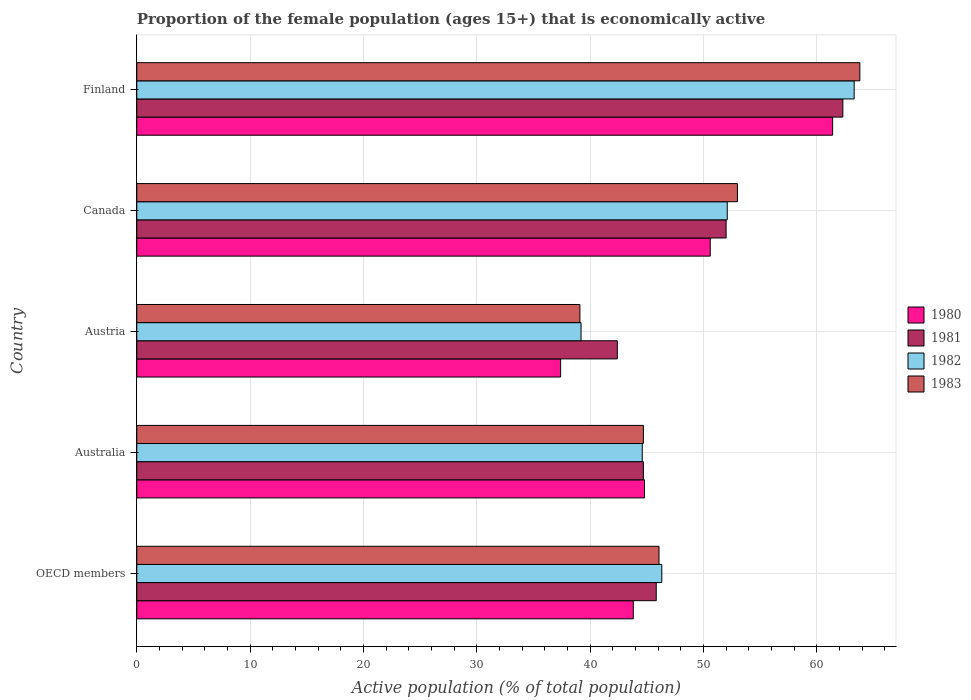Are the number of bars on each tick of the Y-axis equal?
Your response must be concise. Yes. What is the label of the 5th group of bars from the top?
Ensure brevity in your answer.  OECD members. In how many cases, is the number of bars for a given country not equal to the number of legend labels?
Your answer should be compact. 0. What is the proportion of the female population that is economically active in 1980 in Canada?
Your answer should be compact. 50.6. Across all countries, what is the maximum proportion of the female population that is economically active in 1983?
Give a very brief answer. 63.8. Across all countries, what is the minimum proportion of the female population that is economically active in 1981?
Give a very brief answer. 42.4. In which country was the proportion of the female population that is economically active in 1983 maximum?
Provide a short and direct response. Finland. What is the total proportion of the female population that is economically active in 1980 in the graph?
Provide a succinct answer. 238.01. What is the difference between the proportion of the female population that is economically active in 1983 in Austria and that in Canada?
Make the answer very short. -13.9. What is the difference between the proportion of the female population that is economically active in 1982 in OECD members and the proportion of the female population that is economically active in 1981 in Canada?
Make the answer very short. -5.68. What is the average proportion of the female population that is economically active in 1980 per country?
Give a very brief answer. 47.6. What is the difference between the proportion of the female population that is economically active in 1982 and proportion of the female population that is economically active in 1981 in Australia?
Your response must be concise. -0.1. In how many countries, is the proportion of the female population that is economically active in 1983 greater than 52 %?
Your response must be concise. 2. What is the ratio of the proportion of the female population that is economically active in 1983 in Australia to that in Canada?
Provide a succinct answer. 0.84. Is the proportion of the female population that is economically active in 1983 in Austria less than that in Finland?
Ensure brevity in your answer.  Yes. Is the difference between the proportion of the female population that is economically active in 1982 in Australia and Canada greater than the difference between the proportion of the female population that is economically active in 1981 in Australia and Canada?
Offer a terse response. No. What is the difference between the highest and the second highest proportion of the female population that is economically active in 1981?
Give a very brief answer. 10.3. What is the difference between the highest and the lowest proportion of the female population that is economically active in 1982?
Your answer should be very brief. 24.1. In how many countries, is the proportion of the female population that is economically active in 1980 greater than the average proportion of the female population that is economically active in 1980 taken over all countries?
Provide a short and direct response. 2. Is the sum of the proportion of the female population that is economically active in 1981 in Finland and OECD members greater than the maximum proportion of the female population that is economically active in 1980 across all countries?
Ensure brevity in your answer.  Yes. How many bars are there?
Provide a short and direct response. 20. Does the graph contain any zero values?
Keep it short and to the point. No. Where does the legend appear in the graph?
Your response must be concise. Center right. How are the legend labels stacked?
Ensure brevity in your answer.  Vertical. What is the title of the graph?
Offer a very short reply. Proportion of the female population (ages 15+) that is economically active. What is the label or title of the X-axis?
Offer a very short reply. Active population (% of total population). What is the Active population (% of total population) in 1980 in OECD members?
Make the answer very short. 43.81. What is the Active population (% of total population) in 1981 in OECD members?
Offer a terse response. 45.84. What is the Active population (% of total population) of 1982 in OECD members?
Keep it short and to the point. 46.32. What is the Active population (% of total population) of 1983 in OECD members?
Provide a short and direct response. 46.08. What is the Active population (% of total population) in 1980 in Australia?
Your response must be concise. 44.8. What is the Active population (% of total population) of 1981 in Australia?
Give a very brief answer. 44.7. What is the Active population (% of total population) in 1982 in Australia?
Your answer should be very brief. 44.6. What is the Active population (% of total population) of 1983 in Australia?
Your response must be concise. 44.7. What is the Active population (% of total population) in 1980 in Austria?
Offer a very short reply. 37.4. What is the Active population (% of total population) in 1981 in Austria?
Make the answer very short. 42.4. What is the Active population (% of total population) of 1982 in Austria?
Keep it short and to the point. 39.2. What is the Active population (% of total population) in 1983 in Austria?
Keep it short and to the point. 39.1. What is the Active population (% of total population) in 1980 in Canada?
Provide a short and direct response. 50.6. What is the Active population (% of total population) of 1982 in Canada?
Your answer should be compact. 52.1. What is the Active population (% of total population) of 1980 in Finland?
Offer a terse response. 61.4. What is the Active population (% of total population) of 1981 in Finland?
Provide a short and direct response. 62.3. What is the Active population (% of total population) of 1982 in Finland?
Provide a succinct answer. 63.3. What is the Active population (% of total population) of 1983 in Finland?
Your answer should be very brief. 63.8. Across all countries, what is the maximum Active population (% of total population) in 1980?
Your response must be concise. 61.4. Across all countries, what is the maximum Active population (% of total population) of 1981?
Provide a succinct answer. 62.3. Across all countries, what is the maximum Active population (% of total population) in 1982?
Offer a very short reply. 63.3. Across all countries, what is the maximum Active population (% of total population) of 1983?
Ensure brevity in your answer.  63.8. Across all countries, what is the minimum Active population (% of total population) of 1980?
Make the answer very short. 37.4. Across all countries, what is the minimum Active population (% of total population) in 1981?
Offer a very short reply. 42.4. Across all countries, what is the minimum Active population (% of total population) of 1982?
Make the answer very short. 39.2. Across all countries, what is the minimum Active population (% of total population) in 1983?
Provide a short and direct response. 39.1. What is the total Active population (% of total population) in 1980 in the graph?
Give a very brief answer. 238.01. What is the total Active population (% of total population) of 1981 in the graph?
Ensure brevity in your answer.  247.24. What is the total Active population (% of total population) of 1982 in the graph?
Make the answer very short. 245.52. What is the total Active population (% of total population) of 1983 in the graph?
Your answer should be very brief. 246.68. What is the difference between the Active population (% of total population) of 1980 in OECD members and that in Australia?
Your answer should be very brief. -0.99. What is the difference between the Active population (% of total population) of 1981 in OECD members and that in Australia?
Offer a very short reply. 1.14. What is the difference between the Active population (% of total population) in 1982 in OECD members and that in Australia?
Give a very brief answer. 1.72. What is the difference between the Active population (% of total population) of 1983 in OECD members and that in Australia?
Your response must be concise. 1.38. What is the difference between the Active population (% of total population) in 1980 in OECD members and that in Austria?
Your answer should be compact. 6.41. What is the difference between the Active population (% of total population) in 1981 in OECD members and that in Austria?
Your answer should be very brief. 3.44. What is the difference between the Active population (% of total population) of 1982 in OECD members and that in Austria?
Give a very brief answer. 7.12. What is the difference between the Active population (% of total population) in 1983 in OECD members and that in Austria?
Provide a short and direct response. 6.98. What is the difference between the Active population (% of total population) in 1980 in OECD members and that in Canada?
Offer a very short reply. -6.79. What is the difference between the Active population (% of total population) in 1981 in OECD members and that in Canada?
Your response must be concise. -6.16. What is the difference between the Active population (% of total population) in 1982 in OECD members and that in Canada?
Offer a terse response. -5.78. What is the difference between the Active population (% of total population) of 1983 in OECD members and that in Canada?
Offer a very short reply. -6.92. What is the difference between the Active population (% of total population) of 1980 in OECD members and that in Finland?
Offer a terse response. -17.59. What is the difference between the Active population (% of total population) of 1981 in OECD members and that in Finland?
Your response must be concise. -16.46. What is the difference between the Active population (% of total population) in 1982 in OECD members and that in Finland?
Your response must be concise. -16.98. What is the difference between the Active population (% of total population) of 1983 in OECD members and that in Finland?
Ensure brevity in your answer.  -17.72. What is the difference between the Active population (% of total population) of 1980 in Australia and that in Austria?
Offer a terse response. 7.4. What is the difference between the Active population (% of total population) in 1982 in Australia and that in Austria?
Your response must be concise. 5.4. What is the difference between the Active population (% of total population) of 1983 in Australia and that in Austria?
Provide a succinct answer. 5.6. What is the difference between the Active population (% of total population) in 1981 in Australia and that in Canada?
Keep it short and to the point. -7.3. What is the difference between the Active population (% of total population) in 1980 in Australia and that in Finland?
Give a very brief answer. -16.6. What is the difference between the Active population (% of total population) of 1981 in Australia and that in Finland?
Offer a very short reply. -17.6. What is the difference between the Active population (% of total population) in 1982 in Australia and that in Finland?
Your answer should be compact. -18.7. What is the difference between the Active population (% of total population) of 1983 in Australia and that in Finland?
Your answer should be compact. -19.1. What is the difference between the Active population (% of total population) of 1980 in Austria and that in Canada?
Ensure brevity in your answer.  -13.2. What is the difference between the Active population (% of total population) of 1983 in Austria and that in Canada?
Give a very brief answer. -13.9. What is the difference between the Active population (% of total population) of 1981 in Austria and that in Finland?
Keep it short and to the point. -19.9. What is the difference between the Active population (% of total population) in 1982 in Austria and that in Finland?
Your answer should be very brief. -24.1. What is the difference between the Active population (% of total population) in 1983 in Austria and that in Finland?
Ensure brevity in your answer.  -24.7. What is the difference between the Active population (% of total population) of 1982 in Canada and that in Finland?
Your response must be concise. -11.2. What is the difference between the Active population (% of total population) of 1980 in OECD members and the Active population (% of total population) of 1981 in Australia?
Keep it short and to the point. -0.89. What is the difference between the Active population (% of total population) in 1980 in OECD members and the Active population (% of total population) in 1982 in Australia?
Provide a short and direct response. -0.79. What is the difference between the Active population (% of total population) of 1980 in OECD members and the Active population (% of total population) of 1983 in Australia?
Provide a succinct answer. -0.89. What is the difference between the Active population (% of total population) in 1981 in OECD members and the Active population (% of total population) in 1982 in Australia?
Ensure brevity in your answer.  1.24. What is the difference between the Active population (% of total population) of 1981 in OECD members and the Active population (% of total population) of 1983 in Australia?
Your answer should be compact. 1.14. What is the difference between the Active population (% of total population) in 1982 in OECD members and the Active population (% of total population) in 1983 in Australia?
Provide a succinct answer. 1.62. What is the difference between the Active population (% of total population) in 1980 in OECD members and the Active population (% of total population) in 1981 in Austria?
Keep it short and to the point. 1.41. What is the difference between the Active population (% of total population) in 1980 in OECD members and the Active population (% of total population) in 1982 in Austria?
Provide a succinct answer. 4.61. What is the difference between the Active population (% of total population) in 1980 in OECD members and the Active population (% of total population) in 1983 in Austria?
Your answer should be compact. 4.71. What is the difference between the Active population (% of total population) in 1981 in OECD members and the Active population (% of total population) in 1982 in Austria?
Make the answer very short. 6.64. What is the difference between the Active population (% of total population) of 1981 in OECD members and the Active population (% of total population) of 1983 in Austria?
Offer a terse response. 6.74. What is the difference between the Active population (% of total population) in 1982 in OECD members and the Active population (% of total population) in 1983 in Austria?
Provide a succinct answer. 7.22. What is the difference between the Active population (% of total population) in 1980 in OECD members and the Active population (% of total population) in 1981 in Canada?
Keep it short and to the point. -8.19. What is the difference between the Active population (% of total population) of 1980 in OECD members and the Active population (% of total population) of 1982 in Canada?
Ensure brevity in your answer.  -8.29. What is the difference between the Active population (% of total population) of 1980 in OECD members and the Active population (% of total population) of 1983 in Canada?
Your answer should be very brief. -9.19. What is the difference between the Active population (% of total population) of 1981 in OECD members and the Active population (% of total population) of 1982 in Canada?
Ensure brevity in your answer.  -6.26. What is the difference between the Active population (% of total population) in 1981 in OECD members and the Active population (% of total population) in 1983 in Canada?
Provide a short and direct response. -7.16. What is the difference between the Active population (% of total population) of 1982 in OECD members and the Active population (% of total population) of 1983 in Canada?
Offer a terse response. -6.68. What is the difference between the Active population (% of total population) in 1980 in OECD members and the Active population (% of total population) in 1981 in Finland?
Provide a succinct answer. -18.49. What is the difference between the Active population (% of total population) of 1980 in OECD members and the Active population (% of total population) of 1982 in Finland?
Your answer should be very brief. -19.49. What is the difference between the Active population (% of total population) in 1980 in OECD members and the Active population (% of total population) in 1983 in Finland?
Provide a short and direct response. -19.99. What is the difference between the Active population (% of total population) of 1981 in OECD members and the Active population (% of total population) of 1982 in Finland?
Your answer should be very brief. -17.46. What is the difference between the Active population (% of total population) of 1981 in OECD members and the Active population (% of total population) of 1983 in Finland?
Make the answer very short. -17.96. What is the difference between the Active population (% of total population) of 1982 in OECD members and the Active population (% of total population) of 1983 in Finland?
Provide a short and direct response. -17.48. What is the difference between the Active population (% of total population) of 1980 in Australia and the Active population (% of total population) of 1981 in Austria?
Keep it short and to the point. 2.4. What is the difference between the Active population (% of total population) of 1981 in Australia and the Active population (% of total population) of 1982 in Austria?
Make the answer very short. 5.5. What is the difference between the Active population (% of total population) of 1981 in Australia and the Active population (% of total population) of 1983 in Austria?
Give a very brief answer. 5.6. What is the difference between the Active population (% of total population) in 1980 in Australia and the Active population (% of total population) in 1982 in Canada?
Provide a succinct answer. -7.3. What is the difference between the Active population (% of total population) in 1980 in Australia and the Active population (% of total population) in 1981 in Finland?
Your answer should be very brief. -17.5. What is the difference between the Active population (% of total population) in 1980 in Australia and the Active population (% of total population) in 1982 in Finland?
Your response must be concise. -18.5. What is the difference between the Active population (% of total population) of 1980 in Australia and the Active population (% of total population) of 1983 in Finland?
Keep it short and to the point. -19. What is the difference between the Active population (% of total population) in 1981 in Australia and the Active population (% of total population) in 1982 in Finland?
Keep it short and to the point. -18.6. What is the difference between the Active population (% of total population) in 1981 in Australia and the Active population (% of total population) in 1983 in Finland?
Provide a short and direct response. -19.1. What is the difference between the Active population (% of total population) of 1982 in Australia and the Active population (% of total population) of 1983 in Finland?
Your answer should be compact. -19.2. What is the difference between the Active population (% of total population) in 1980 in Austria and the Active population (% of total population) in 1981 in Canada?
Ensure brevity in your answer.  -14.6. What is the difference between the Active population (% of total population) of 1980 in Austria and the Active population (% of total population) of 1982 in Canada?
Your answer should be compact. -14.7. What is the difference between the Active population (% of total population) in 1980 in Austria and the Active population (% of total population) in 1983 in Canada?
Give a very brief answer. -15.6. What is the difference between the Active population (% of total population) in 1982 in Austria and the Active population (% of total population) in 1983 in Canada?
Give a very brief answer. -13.8. What is the difference between the Active population (% of total population) of 1980 in Austria and the Active population (% of total population) of 1981 in Finland?
Provide a short and direct response. -24.9. What is the difference between the Active population (% of total population) of 1980 in Austria and the Active population (% of total population) of 1982 in Finland?
Your answer should be very brief. -25.9. What is the difference between the Active population (% of total population) of 1980 in Austria and the Active population (% of total population) of 1983 in Finland?
Offer a very short reply. -26.4. What is the difference between the Active population (% of total population) in 1981 in Austria and the Active population (% of total population) in 1982 in Finland?
Your answer should be compact. -20.9. What is the difference between the Active population (% of total population) in 1981 in Austria and the Active population (% of total population) in 1983 in Finland?
Make the answer very short. -21.4. What is the difference between the Active population (% of total population) in 1982 in Austria and the Active population (% of total population) in 1983 in Finland?
Provide a short and direct response. -24.6. What is the difference between the Active population (% of total population) in 1980 in Canada and the Active population (% of total population) in 1981 in Finland?
Your response must be concise. -11.7. What is the difference between the Active population (% of total population) in 1980 in Canada and the Active population (% of total population) in 1983 in Finland?
Keep it short and to the point. -13.2. What is the difference between the Active population (% of total population) in 1981 in Canada and the Active population (% of total population) in 1983 in Finland?
Offer a terse response. -11.8. What is the average Active population (% of total population) of 1980 per country?
Give a very brief answer. 47.6. What is the average Active population (% of total population) of 1981 per country?
Keep it short and to the point. 49.45. What is the average Active population (% of total population) in 1982 per country?
Provide a short and direct response. 49.1. What is the average Active population (% of total population) in 1983 per country?
Your answer should be very brief. 49.34. What is the difference between the Active population (% of total population) in 1980 and Active population (% of total population) in 1981 in OECD members?
Provide a short and direct response. -2.03. What is the difference between the Active population (% of total population) of 1980 and Active population (% of total population) of 1982 in OECD members?
Your answer should be compact. -2.52. What is the difference between the Active population (% of total population) in 1980 and Active population (% of total population) in 1983 in OECD members?
Give a very brief answer. -2.27. What is the difference between the Active population (% of total population) in 1981 and Active population (% of total population) in 1982 in OECD members?
Your response must be concise. -0.49. What is the difference between the Active population (% of total population) of 1981 and Active population (% of total population) of 1983 in OECD members?
Offer a terse response. -0.24. What is the difference between the Active population (% of total population) of 1982 and Active population (% of total population) of 1983 in OECD members?
Make the answer very short. 0.25. What is the difference between the Active population (% of total population) of 1980 and Active population (% of total population) of 1983 in Australia?
Your answer should be compact. 0.1. What is the difference between the Active population (% of total population) in 1981 and Active population (% of total population) in 1982 in Australia?
Provide a succinct answer. 0.1. What is the difference between the Active population (% of total population) in 1981 and Active population (% of total population) in 1983 in Australia?
Keep it short and to the point. 0. What is the difference between the Active population (% of total population) in 1982 and Active population (% of total population) in 1983 in Australia?
Give a very brief answer. -0.1. What is the difference between the Active population (% of total population) in 1980 and Active population (% of total population) in 1981 in Austria?
Your response must be concise. -5. What is the difference between the Active population (% of total population) of 1980 and Active population (% of total population) of 1983 in Austria?
Provide a succinct answer. -1.7. What is the difference between the Active population (% of total population) in 1981 and Active population (% of total population) in 1982 in Austria?
Your answer should be compact. 3.2. What is the difference between the Active population (% of total population) in 1981 and Active population (% of total population) in 1983 in Austria?
Your response must be concise. 3.3. What is the difference between the Active population (% of total population) in 1982 and Active population (% of total population) in 1983 in Austria?
Offer a very short reply. 0.1. What is the difference between the Active population (% of total population) in 1980 and Active population (% of total population) in 1981 in Canada?
Offer a terse response. -1.4. What is the difference between the Active population (% of total population) in 1981 and Active population (% of total population) in 1982 in Canada?
Your answer should be compact. -0.1. What is the difference between the Active population (% of total population) in 1981 and Active population (% of total population) in 1983 in Canada?
Offer a very short reply. -1. What is the difference between the Active population (% of total population) of 1982 and Active population (% of total population) of 1983 in Canada?
Your answer should be very brief. -0.9. What is the difference between the Active population (% of total population) of 1980 and Active population (% of total population) of 1981 in Finland?
Offer a very short reply. -0.9. What is the difference between the Active population (% of total population) of 1980 and Active population (% of total population) of 1982 in Finland?
Offer a terse response. -1.9. What is the difference between the Active population (% of total population) of 1981 and Active population (% of total population) of 1982 in Finland?
Provide a short and direct response. -1. What is the difference between the Active population (% of total population) in 1981 and Active population (% of total population) in 1983 in Finland?
Your answer should be very brief. -1.5. What is the difference between the Active population (% of total population) of 1982 and Active population (% of total population) of 1983 in Finland?
Provide a succinct answer. -0.5. What is the ratio of the Active population (% of total population) of 1980 in OECD members to that in Australia?
Make the answer very short. 0.98. What is the ratio of the Active population (% of total population) of 1981 in OECD members to that in Australia?
Offer a terse response. 1.03. What is the ratio of the Active population (% of total population) of 1982 in OECD members to that in Australia?
Offer a very short reply. 1.04. What is the ratio of the Active population (% of total population) in 1983 in OECD members to that in Australia?
Ensure brevity in your answer.  1.03. What is the ratio of the Active population (% of total population) in 1980 in OECD members to that in Austria?
Your answer should be very brief. 1.17. What is the ratio of the Active population (% of total population) in 1981 in OECD members to that in Austria?
Your answer should be compact. 1.08. What is the ratio of the Active population (% of total population) of 1982 in OECD members to that in Austria?
Offer a very short reply. 1.18. What is the ratio of the Active population (% of total population) in 1983 in OECD members to that in Austria?
Ensure brevity in your answer.  1.18. What is the ratio of the Active population (% of total population) in 1980 in OECD members to that in Canada?
Your answer should be compact. 0.87. What is the ratio of the Active population (% of total population) in 1981 in OECD members to that in Canada?
Your answer should be compact. 0.88. What is the ratio of the Active population (% of total population) in 1982 in OECD members to that in Canada?
Your answer should be very brief. 0.89. What is the ratio of the Active population (% of total population) in 1983 in OECD members to that in Canada?
Make the answer very short. 0.87. What is the ratio of the Active population (% of total population) of 1980 in OECD members to that in Finland?
Ensure brevity in your answer.  0.71. What is the ratio of the Active population (% of total population) in 1981 in OECD members to that in Finland?
Provide a short and direct response. 0.74. What is the ratio of the Active population (% of total population) of 1982 in OECD members to that in Finland?
Make the answer very short. 0.73. What is the ratio of the Active population (% of total population) of 1983 in OECD members to that in Finland?
Give a very brief answer. 0.72. What is the ratio of the Active population (% of total population) in 1980 in Australia to that in Austria?
Your answer should be very brief. 1.2. What is the ratio of the Active population (% of total population) of 1981 in Australia to that in Austria?
Your response must be concise. 1.05. What is the ratio of the Active population (% of total population) of 1982 in Australia to that in Austria?
Provide a succinct answer. 1.14. What is the ratio of the Active population (% of total population) in 1983 in Australia to that in Austria?
Your response must be concise. 1.14. What is the ratio of the Active population (% of total population) of 1980 in Australia to that in Canada?
Your response must be concise. 0.89. What is the ratio of the Active population (% of total population) in 1981 in Australia to that in Canada?
Keep it short and to the point. 0.86. What is the ratio of the Active population (% of total population) in 1982 in Australia to that in Canada?
Provide a short and direct response. 0.86. What is the ratio of the Active population (% of total population) of 1983 in Australia to that in Canada?
Offer a terse response. 0.84. What is the ratio of the Active population (% of total population) of 1980 in Australia to that in Finland?
Keep it short and to the point. 0.73. What is the ratio of the Active population (% of total population) in 1981 in Australia to that in Finland?
Offer a terse response. 0.72. What is the ratio of the Active population (% of total population) of 1982 in Australia to that in Finland?
Make the answer very short. 0.7. What is the ratio of the Active population (% of total population) of 1983 in Australia to that in Finland?
Give a very brief answer. 0.7. What is the ratio of the Active population (% of total population) of 1980 in Austria to that in Canada?
Your answer should be compact. 0.74. What is the ratio of the Active population (% of total population) in 1981 in Austria to that in Canada?
Offer a terse response. 0.82. What is the ratio of the Active population (% of total population) of 1982 in Austria to that in Canada?
Offer a very short reply. 0.75. What is the ratio of the Active population (% of total population) of 1983 in Austria to that in Canada?
Provide a succinct answer. 0.74. What is the ratio of the Active population (% of total population) of 1980 in Austria to that in Finland?
Your response must be concise. 0.61. What is the ratio of the Active population (% of total population) in 1981 in Austria to that in Finland?
Keep it short and to the point. 0.68. What is the ratio of the Active population (% of total population) in 1982 in Austria to that in Finland?
Offer a very short reply. 0.62. What is the ratio of the Active population (% of total population) of 1983 in Austria to that in Finland?
Offer a terse response. 0.61. What is the ratio of the Active population (% of total population) of 1980 in Canada to that in Finland?
Give a very brief answer. 0.82. What is the ratio of the Active population (% of total population) of 1981 in Canada to that in Finland?
Offer a very short reply. 0.83. What is the ratio of the Active population (% of total population) of 1982 in Canada to that in Finland?
Provide a succinct answer. 0.82. What is the ratio of the Active population (% of total population) of 1983 in Canada to that in Finland?
Offer a terse response. 0.83. What is the difference between the highest and the second highest Active population (% of total population) of 1980?
Make the answer very short. 10.8. What is the difference between the highest and the second highest Active population (% of total population) of 1981?
Your answer should be compact. 10.3. What is the difference between the highest and the second highest Active population (% of total population) in 1982?
Ensure brevity in your answer.  11.2. What is the difference between the highest and the lowest Active population (% of total population) in 1980?
Your response must be concise. 24. What is the difference between the highest and the lowest Active population (% of total population) in 1982?
Keep it short and to the point. 24.1. What is the difference between the highest and the lowest Active population (% of total population) of 1983?
Your answer should be compact. 24.7. 